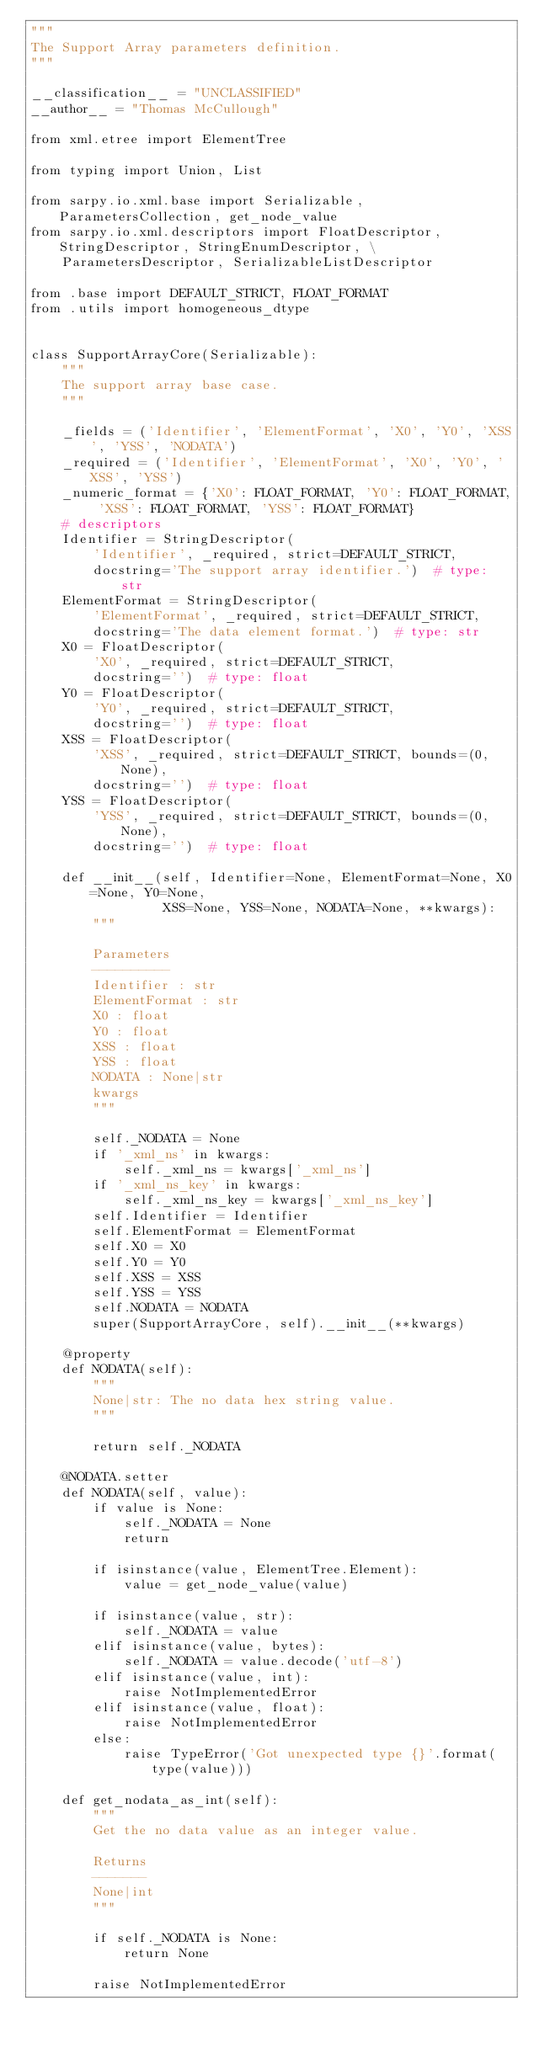Convert code to text. <code><loc_0><loc_0><loc_500><loc_500><_Python_>"""
The Support Array parameters definition.
"""

__classification__ = "UNCLASSIFIED"
__author__ = "Thomas McCullough"

from xml.etree import ElementTree

from typing import Union, List

from sarpy.io.xml.base import Serializable, ParametersCollection, get_node_value
from sarpy.io.xml.descriptors import FloatDescriptor, StringDescriptor, StringEnumDescriptor, \
    ParametersDescriptor, SerializableListDescriptor

from .base import DEFAULT_STRICT, FLOAT_FORMAT
from .utils import homogeneous_dtype


class SupportArrayCore(Serializable):
    """
    The support array base case.
    """

    _fields = ('Identifier', 'ElementFormat', 'X0', 'Y0', 'XSS', 'YSS', 'NODATA')
    _required = ('Identifier', 'ElementFormat', 'X0', 'Y0', 'XSS', 'YSS')
    _numeric_format = {'X0': FLOAT_FORMAT, 'Y0': FLOAT_FORMAT, 'XSS': FLOAT_FORMAT, 'YSS': FLOAT_FORMAT}
    # descriptors
    Identifier = StringDescriptor(
        'Identifier', _required, strict=DEFAULT_STRICT,
        docstring='The support array identifier.')  # type: str
    ElementFormat = StringDescriptor(
        'ElementFormat', _required, strict=DEFAULT_STRICT,
        docstring='The data element format.')  # type: str
    X0 = FloatDescriptor(
        'X0', _required, strict=DEFAULT_STRICT,
        docstring='')  # type: float
    Y0 = FloatDescriptor(
        'Y0', _required, strict=DEFAULT_STRICT,
        docstring='')  # type: float
    XSS = FloatDescriptor(
        'XSS', _required, strict=DEFAULT_STRICT, bounds=(0, None),
        docstring='')  # type: float
    YSS = FloatDescriptor(
        'YSS', _required, strict=DEFAULT_STRICT, bounds=(0, None),
        docstring='')  # type: float

    def __init__(self, Identifier=None, ElementFormat=None, X0=None, Y0=None,
                 XSS=None, YSS=None, NODATA=None, **kwargs):
        """

        Parameters
        ----------
        Identifier : str
        ElementFormat : str
        X0 : float
        Y0 : float
        XSS : float
        YSS : float
        NODATA : None|str
        kwargs
        """

        self._NODATA = None
        if '_xml_ns' in kwargs:
            self._xml_ns = kwargs['_xml_ns']
        if '_xml_ns_key' in kwargs:
            self._xml_ns_key = kwargs['_xml_ns_key']
        self.Identifier = Identifier
        self.ElementFormat = ElementFormat
        self.X0 = X0
        self.Y0 = Y0
        self.XSS = XSS
        self.YSS = YSS
        self.NODATA = NODATA
        super(SupportArrayCore, self).__init__(**kwargs)

    @property
    def NODATA(self):
        """
        None|str: The no data hex string value.
        """

        return self._NODATA

    @NODATA.setter
    def NODATA(self, value):
        if value is None:
            self._NODATA = None
            return

        if isinstance(value, ElementTree.Element):
            value = get_node_value(value)

        if isinstance(value, str):
            self._NODATA = value
        elif isinstance(value, bytes):
            self._NODATA = value.decode('utf-8')
        elif isinstance(value, int):
            raise NotImplementedError
        elif isinstance(value, float):
            raise NotImplementedError
        else:
            raise TypeError('Got unexpected type {}'.format(type(value)))

    def get_nodata_as_int(self):
        """
        Get the no data value as an integer value.

        Returns
        -------
        None|int
        """

        if self._NODATA is None:
            return None

        raise NotImplementedError
</code> 